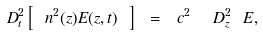<formula> <loc_0><loc_0><loc_500><loc_500>\ D _ { t } ^ { 2 } \left [ \ n ^ { 2 } ( z ) E ( z , t ) \ \right ] \ = \ c ^ { 2 } \ \ D _ { z } ^ { 2 } \ E ,</formula> 